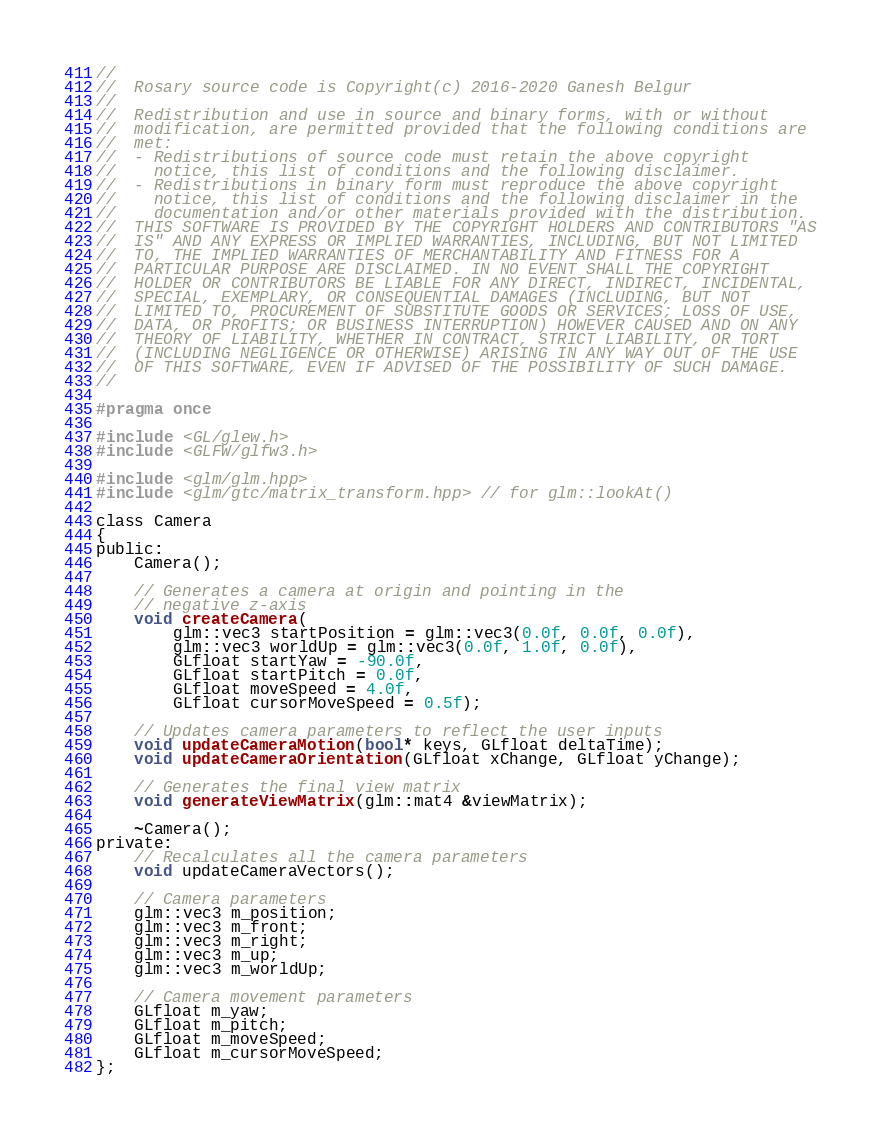<code> <loc_0><loc_0><loc_500><loc_500><_C_>//
//  Rosary source code is Copyright(c) 2016-2020 Ganesh Belgur
//
//  Redistribution and use in source and binary forms, with or without
//  modification, are permitted provided that the following conditions are
//  met:
//  - Redistributions of source code must retain the above copyright
//    notice, this list of conditions and the following disclaimer.
//  - Redistributions in binary form must reproduce the above copyright
//    notice, this list of conditions and the following disclaimer in the
//    documentation and/or other materials provided with the distribution.
//  THIS SOFTWARE IS PROVIDED BY THE COPYRIGHT HOLDERS AND CONTRIBUTORS "AS
//  IS" AND ANY EXPRESS OR IMPLIED WARRANTIES, INCLUDING, BUT NOT LIMITED
//  TO, THE IMPLIED WARRANTIES OF MERCHANTABILITY AND FITNESS FOR A
//  PARTICULAR PURPOSE ARE DISCLAIMED. IN NO EVENT SHALL THE COPYRIGHT
//  HOLDER OR CONTRIBUTORS BE LIABLE FOR ANY DIRECT, INDIRECT, INCIDENTAL,
//  SPECIAL, EXEMPLARY, OR CONSEQUENTIAL DAMAGES (INCLUDING, BUT NOT
//  LIMITED TO, PROCUREMENT OF SUBSTITUTE GOODS OR SERVICES; LOSS OF USE,
//  DATA, OR PROFITS; OR BUSINESS INTERRUPTION) HOWEVER CAUSED AND ON ANY
//  THEORY OF LIABILITY, WHETHER IN CONTRACT, STRICT LIABILITY, OR TORT
//  (INCLUDING NEGLIGENCE OR OTHERWISE) ARISING IN ANY WAY OUT OF THE USE
//  OF THIS SOFTWARE, EVEN IF ADVISED OF THE POSSIBILITY OF SUCH DAMAGE.
//

#pragma once

#include <GL/glew.h>
#include <GLFW/glfw3.h>

#include <glm/glm.hpp>
#include <glm/gtc/matrix_transform.hpp> // for glm::lookAt()

class Camera
{
public:
    Camera();

    // Generates a camera at origin and pointing in the
    // negative z-axis
    void createCamera(
        glm::vec3 startPosition = glm::vec3(0.0f, 0.0f, 0.0f),
        glm::vec3 worldUp = glm::vec3(0.0f, 1.0f, 0.0f),
        GLfloat startYaw = -90.0f,
        GLfloat startPitch = 0.0f,
        GLfloat moveSpeed = 4.0f,
        GLfloat cursorMoveSpeed = 0.5f);

    // Updates camera parameters to reflect the user inputs
    void updateCameraMotion(bool* keys, GLfloat deltaTime);
    void updateCameraOrientation(GLfloat xChange, GLfloat yChange);
    
    // Generates the final view matrix 
    void generateViewMatrix(glm::mat4 &viewMatrix);

    ~Camera();
private:
    // Recalculates all the camera parameters
    void updateCameraVectors();

    // Camera parameters
    glm::vec3 m_position;
    glm::vec3 m_front;
    glm::vec3 m_right;
    glm::vec3 m_up;
    glm::vec3 m_worldUp;

    // Camera movement parameters
    GLfloat m_yaw;
    GLfloat m_pitch;
    GLfloat m_moveSpeed;
    GLfloat m_cursorMoveSpeed;
};
</code> 